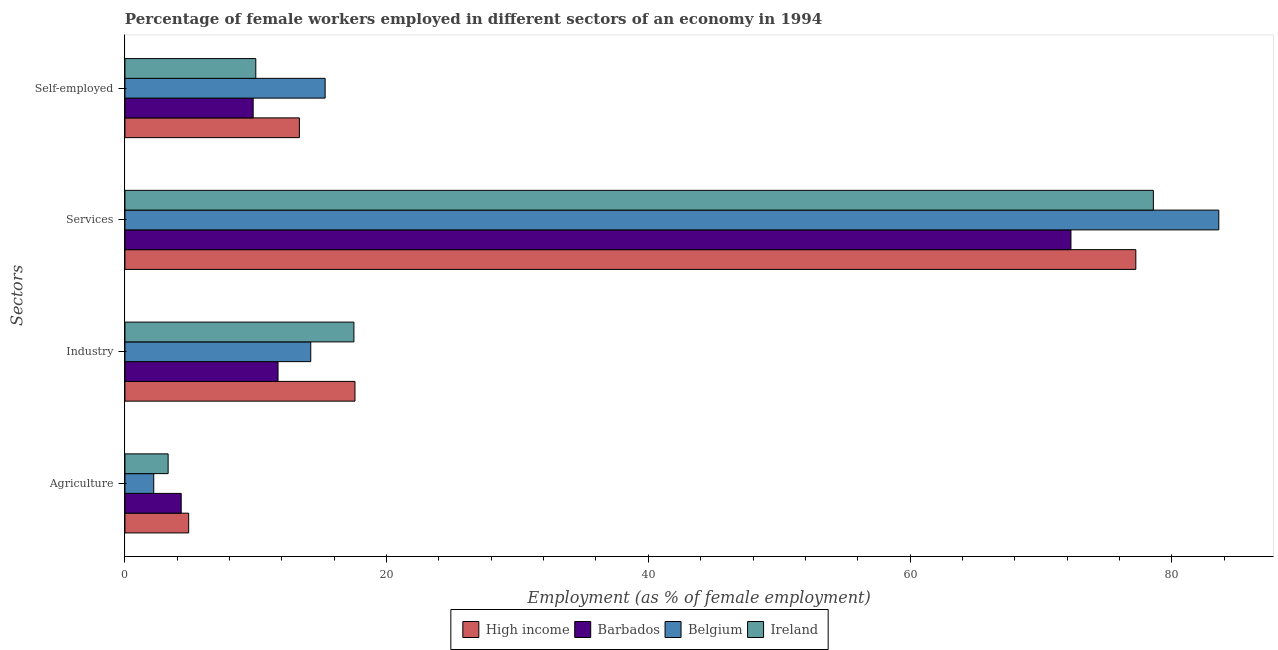How many different coloured bars are there?
Offer a very short reply. 4. How many groups of bars are there?
Provide a short and direct response. 4. Are the number of bars per tick equal to the number of legend labels?
Your response must be concise. Yes. Are the number of bars on each tick of the Y-axis equal?
Keep it short and to the point. Yes. How many bars are there on the 4th tick from the bottom?
Your answer should be very brief. 4. What is the label of the 3rd group of bars from the top?
Provide a short and direct response. Industry. What is the percentage of female workers in agriculture in High income?
Make the answer very short. 4.87. Across all countries, what is the maximum percentage of female workers in industry?
Keep it short and to the point. 17.58. Across all countries, what is the minimum percentage of self employed female workers?
Provide a succinct answer. 9.8. In which country was the percentage of female workers in services minimum?
Give a very brief answer. Barbados. What is the total percentage of female workers in services in the graph?
Ensure brevity in your answer.  311.76. What is the difference between the percentage of female workers in agriculture in High income and that in Belgium?
Ensure brevity in your answer.  2.67. What is the difference between the percentage of self employed female workers in Ireland and the percentage of female workers in agriculture in Belgium?
Ensure brevity in your answer.  7.8. What is the average percentage of female workers in services per country?
Give a very brief answer. 77.94. What is the difference between the percentage of female workers in industry and percentage of self employed female workers in Belgium?
Make the answer very short. -1.1. In how many countries, is the percentage of female workers in services greater than 44 %?
Offer a very short reply. 4. What is the ratio of the percentage of female workers in services in Ireland to that in Belgium?
Offer a terse response. 0.94. Is the percentage of self employed female workers in Barbados less than that in High income?
Give a very brief answer. Yes. What is the difference between the highest and the second highest percentage of female workers in services?
Provide a short and direct response. 5. What is the difference between the highest and the lowest percentage of self employed female workers?
Offer a terse response. 5.5. Is it the case that in every country, the sum of the percentage of female workers in agriculture and percentage of self employed female workers is greater than the sum of percentage of female workers in services and percentage of female workers in industry?
Provide a succinct answer. Yes. What does the 2nd bar from the top in Self-employed represents?
Keep it short and to the point. Belgium. What does the 2nd bar from the bottom in Agriculture represents?
Provide a succinct answer. Barbados. Are all the bars in the graph horizontal?
Provide a short and direct response. Yes. How many countries are there in the graph?
Your response must be concise. 4. What is the difference between two consecutive major ticks on the X-axis?
Offer a very short reply. 20. Does the graph contain grids?
Keep it short and to the point. No. Where does the legend appear in the graph?
Ensure brevity in your answer.  Bottom center. How many legend labels are there?
Offer a very short reply. 4. What is the title of the graph?
Your response must be concise. Percentage of female workers employed in different sectors of an economy in 1994. What is the label or title of the X-axis?
Provide a succinct answer. Employment (as % of female employment). What is the label or title of the Y-axis?
Provide a succinct answer. Sectors. What is the Employment (as % of female employment) in High income in Agriculture?
Give a very brief answer. 4.87. What is the Employment (as % of female employment) of Barbados in Agriculture?
Offer a very short reply. 4.3. What is the Employment (as % of female employment) of Belgium in Agriculture?
Give a very brief answer. 2.2. What is the Employment (as % of female employment) of Ireland in Agriculture?
Your response must be concise. 3.3. What is the Employment (as % of female employment) of High income in Industry?
Keep it short and to the point. 17.58. What is the Employment (as % of female employment) of Barbados in Industry?
Offer a very short reply. 11.7. What is the Employment (as % of female employment) of Belgium in Industry?
Your answer should be very brief. 14.2. What is the Employment (as % of female employment) in Ireland in Industry?
Offer a very short reply. 17.5. What is the Employment (as % of female employment) in High income in Services?
Offer a very short reply. 77.26. What is the Employment (as % of female employment) of Barbados in Services?
Provide a short and direct response. 72.3. What is the Employment (as % of female employment) in Belgium in Services?
Offer a very short reply. 83.6. What is the Employment (as % of female employment) of Ireland in Services?
Your answer should be very brief. 78.6. What is the Employment (as % of female employment) of High income in Self-employed?
Offer a terse response. 13.33. What is the Employment (as % of female employment) in Barbados in Self-employed?
Ensure brevity in your answer.  9.8. What is the Employment (as % of female employment) in Belgium in Self-employed?
Ensure brevity in your answer.  15.3. What is the Employment (as % of female employment) of Ireland in Self-employed?
Keep it short and to the point. 10. Across all Sectors, what is the maximum Employment (as % of female employment) in High income?
Ensure brevity in your answer.  77.26. Across all Sectors, what is the maximum Employment (as % of female employment) in Barbados?
Offer a very short reply. 72.3. Across all Sectors, what is the maximum Employment (as % of female employment) in Belgium?
Offer a very short reply. 83.6. Across all Sectors, what is the maximum Employment (as % of female employment) in Ireland?
Provide a succinct answer. 78.6. Across all Sectors, what is the minimum Employment (as % of female employment) in High income?
Make the answer very short. 4.87. Across all Sectors, what is the minimum Employment (as % of female employment) of Barbados?
Offer a very short reply. 4.3. Across all Sectors, what is the minimum Employment (as % of female employment) of Belgium?
Your answer should be very brief. 2.2. Across all Sectors, what is the minimum Employment (as % of female employment) in Ireland?
Offer a very short reply. 3.3. What is the total Employment (as % of female employment) of High income in the graph?
Provide a succinct answer. 113.04. What is the total Employment (as % of female employment) in Barbados in the graph?
Your answer should be very brief. 98.1. What is the total Employment (as % of female employment) in Belgium in the graph?
Ensure brevity in your answer.  115.3. What is the total Employment (as % of female employment) of Ireland in the graph?
Your response must be concise. 109.4. What is the difference between the Employment (as % of female employment) of High income in Agriculture and that in Industry?
Your answer should be compact. -12.71. What is the difference between the Employment (as % of female employment) of High income in Agriculture and that in Services?
Offer a terse response. -72.39. What is the difference between the Employment (as % of female employment) in Barbados in Agriculture and that in Services?
Your answer should be compact. -68. What is the difference between the Employment (as % of female employment) of Belgium in Agriculture and that in Services?
Offer a terse response. -81.4. What is the difference between the Employment (as % of female employment) of Ireland in Agriculture and that in Services?
Provide a succinct answer. -75.3. What is the difference between the Employment (as % of female employment) of High income in Agriculture and that in Self-employed?
Make the answer very short. -8.46. What is the difference between the Employment (as % of female employment) in Barbados in Agriculture and that in Self-employed?
Your answer should be compact. -5.5. What is the difference between the Employment (as % of female employment) in Belgium in Agriculture and that in Self-employed?
Your response must be concise. -13.1. What is the difference between the Employment (as % of female employment) in Ireland in Agriculture and that in Self-employed?
Give a very brief answer. -6.7. What is the difference between the Employment (as % of female employment) in High income in Industry and that in Services?
Provide a succinct answer. -59.68. What is the difference between the Employment (as % of female employment) in Barbados in Industry and that in Services?
Make the answer very short. -60.6. What is the difference between the Employment (as % of female employment) in Belgium in Industry and that in Services?
Make the answer very short. -69.4. What is the difference between the Employment (as % of female employment) in Ireland in Industry and that in Services?
Offer a very short reply. -61.1. What is the difference between the Employment (as % of female employment) in High income in Industry and that in Self-employed?
Provide a short and direct response. 4.25. What is the difference between the Employment (as % of female employment) of Barbados in Industry and that in Self-employed?
Provide a short and direct response. 1.9. What is the difference between the Employment (as % of female employment) in Ireland in Industry and that in Self-employed?
Keep it short and to the point. 7.5. What is the difference between the Employment (as % of female employment) of High income in Services and that in Self-employed?
Provide a succinct answer. 63.93. What is the difference between the Employment (as % of female employment) in Barbados in Services and that in Self-employed?
Your answer should be compact. 62.5. What is the difference between the Employment (as % of female employment) of Belgium in Services and that in Self-employed?
Provide a short and direct response. 68.3. What is the difference between the Employment (as % of female employment) in Ireland in Services and that in Self-employed?
Your response must be concise. 68.6. What is the difference between the Employment (as % of female employment) in High income in Agriculture and the Employment (as % of female employment) in Barbados in Industry?
Give a very brief answer. -6.83. What is the difference between the Employment (as % of female employment) of High income in Agriculture and the Employment (as % of female employment) of Belgium in Industry?
Offer a very short reply. -9.33. What is the difference between the Employment (as % of female employment) of High income in Agriculture and the Employment (as % of female employment) of Ireland in Industry?
Provide a succinct answer. -12.63. What is the difference between the Employment (as % of female employment) in Belgium in Agriculture and the Employment (as % of female employment) in Ireland in Industry?
Make the answer very short. -15.3. What is the difference between the Employment (as % of female employment) of High income in Agriculture and the Employment (as % of female employment) of Barbados in Services?
Offer a very short reply. -67.43. What is the difference between the Employment (as % of female employment) of High income in Agriculture and the Employment (as % of female employment) of Belgium in Services?
Offer a very short reply. -78.73. What is the difference between the Employment (as % of female employment) in High income in Agriculture and the Employment (as % of female employment) in Ireland in Services?
Your answer should be compact. -73.73. What is the difference between the Employment (as % of female employment) of Barbados in Agriculture and the Employment (as % of female employment) of Belgium in Services?
Give a very brief answer. -79.3. What is the difference between the Employment (as % of female employment) in Barbados in Agriculture and the Employment (as % of female employment) in Ireland in Services?
Your response must be concise. -74.3. What is the difference between the Employment (as % of female employment) of Belgium in Agriculture and the Employment (as % of female employment) of Ireland in Services?
Provide a succinct answer. -76.4. What is the difference between the Employment (as % of female employment) in High income in Agriculture and the Employment (as % of female employment) in Barbados in Self-employed?
Provide a short and direct response. -4.93. What is the difference between the Employment (as % of female employment) of High income in Agriculture and the Employment (as % of female employment) of Belgium in Self-employed?
Provide a succinct answer. -10.43. What is the difference between the Employment (as % of female employment) of High income in Agriculture and the Employment (as % of female employment) of Ireland in Self-employed?
Provide a succinct answer. -5.13. What is the difference between the Employment (as % of female employment) of Barbados in Agriculture and the Employment (as % of female employment) of Ireland in Self-employed?
Offer a terse response. -5.7. What is the difference between the Employment (as % of female employment) in Belgium in Agriculture and the Employment (as % of female employment) in Ireland in Self-employed?
Keep it short and to the point. -7.8. What is the difference between the Employment (as % of female employment) of High income in Industry and the Employment (as % of female employment) of Barbados in Services?
Keep it short and to the point. -54.72. What is the difference between the Employment (as % of female employment) in High income in Industry and the Employment (as % of female employment) in Belgium in Services?
Your answer should be compact. -66.02. What is the difference between the Employment (as % of female employment) of High income in Industry and the Employment (as % of female employment) of Ireland in Services?
Provide a succinct answer. -61.02. What is the difference between the Employment (as % of female employment) of Barbados in Industry and the Employment (as % of female employment) of Belgium in Services?
Ensure brevity in your answer.  -71.9. What is the difference between the Employment (as % of female employment) of Barbados in Industry and the Employment (as % of female employment) of Ireland in Services?
Your answer should be compact. -66.9. What is the difference between the Employment (as % of female employment) in Belgium in Industry and the Employment (as % of female employment) in Ireland in Services?
Offer a terse response. -64.4. What is the difference between the Employment (as % of female employment) in High income in Industry and the Employment (as % of female employment) in Barbados in Self-employed?
Provide a succinct answer. 7.78. What is the difference between the Employment (as % of female employment) in High income in Industry and the Employment (as % of female employment) in Belgium in Self-employed?
Offer a terse response. 2.28. What is the difference between the Employment (as % of female employment) in High income in Industry and the Employment (as % of female employment) in Ireland in Self-employed?
Your response must be concise. 7.58. What is the difference between the Employment (as % of female employment) in Belgium in Industry and the Employment (as % of female employment) in Ireland in Self-employed?
Provide a short and direct response. 4.2. What is the difference between the Employment (as % of female employment) of High income in Services and the Employment (as % of female employment) of Barbados in Self-employed?
Ensure brevity in your answer.  67.46. What is the difference between the Employment (as % of female employment) of High income in Services and the Employment (as % of female employment) of Belgium in Self-employed?
Provide a succinct answer. 61.96. What is the difference between the Employment (as % of female employment) in High income in Services and the Employment (as % of female employment) in Ireland in Self-employed?
Your response must be concise. 67.26. What is the difference between the Employment (as % of female employment) of Barbados in Services and the Employment (as % of female employment) of Belgium in Self-employed?
Offer a terse response. 57. What is the difference between the Employment (as % of female employment) of Barbados in Services and the Employment (as % of female employment) of Ireland in Self-employed?
Provide a short and direct response. 62.3. What is the difference between the Employment (as % of female employment) of Belgium in Services and the Employment (as % of female employment) of Ireland in Self-employed?
Keep it short and to the point. 73.6. What is the average Employment (as % of female employment) of High income per Sectors?
Your answer should be compact. 28.26. What is the average Employment (as % of female employment) in Barbados per Sectors?
Ensure brevity in your answer.  24.52. What is the average Employment (as % of female employment) in Belgium per Sectors?
Make the answer very short. 28.82. What is the average Employment (as % of female employment) in Ireland per Sectors?
Make the answer very short. 27.35. What is the difference between the Employment (as % of female employment) of High income and Employment (as % of female employment) of Barbados in Agriculture?
Offer a terse response. 0.57. What is the difference between the Employment (as % of female employment) of High income and Employment (as % of female employment) of Belgium in Agriculture?
Make the answer very short. 2.67. What is the difference between the Employment (as % of female employment) in High income and Employment (as % of female employment) in Ireland in Agriculture?
Provide a short and direct response. 1.57. What is the difference between the Employment (as % of female employment) in Barbados and Employment (as % of female employment) in Belgium in Agriculture?
Offer a very short reply. 2.1. What is the difference between the Employment (as % of female employment) of Belgium and Employment (as % of female employment) of Ireland in Agriculture?
Ensure brevity in your answer.  -1.1. What is the difference between the Employment (as % of female employment) of High income and Employment (as % of female employment) of Barbados in Industry?
Your answer should be compact. 5.88. What is the difference between the Employment (as % of female employment) of High income and Employment (as % of female employment) of Belgium in Industry?
Offer a very short reply. 3.38. What is the difference between the Employment (as % of female employment) in High income and Employment (as % of female employment) in Ireland in Industry?
Ensure brevity in your answer.  0.08. What is the difference between the Employment (as % of female employment) in Barbados and Employment (as % of female employment) in Ireland in Industry?
Your answer should be compact. -5.8. What is the difference between the Employment (as % of female employment) of High income and Employment (as % of female employment) of Barbados in Services?
Offer a terse response. 4.96. What is the difference between the Employment (as % of female employment) of High income and Employment (as % of female employment) of Belgium in Services?
Offer a terse response. -6.34. What is the difference between the Employment (as % of female employment) of High income and Employment (as % of female employment) of Ireland in Services?
Ensure brevity in your answer.  -1.34. What is the difference between the Employment (as % of female employment) of High income and Employment (as % of female employment) of Barbados in Self-employed?
Provide a succinct answer. 3.53. What is the difference between the Employment (as % of female employment) in High income and Employment (as % of female employment) in Belgium in Self-employed?
Your response must be concise. -1.97. What is the difference between the Employment (as % of female employment) in High income and Employment (as % of female employment) in Ireland in Self-employed?
Ensure brevity in your answer.  3.33. What is the difference between the Employment (as % of female employment) of Barbados and Employment (as % of female employment) of Belgium in Self-employed?
Provide a succinct answer. -5.5. What is the difference between the Employment (as % of female employment) in Barbados and Employment (as % of female employment) in Ireland in Self-employed?
Provide a succinct answer. -0.2. What is the difference between the Employment (as % of female employment) in Belgium and Employment (as % of female employment) in Ireland in Self-employed?
Make the answer very short. 5.3. What is the ratio of the Employment (as % of female employment) of High income in Agriculture to that in Industry?
Offer a terse response. 0.28. What is the ratio of the Employment (as % of female employment) of Barbados in Agriculture to that in Industry?
Keep it short and to the point. 0.37. What is the ratio of the Employment (as % of female employment) in Belgium in Agriculture to that in Industry?
Your response must be concise. 0.15. What is the ratio of the Employment (as % of female employment) of Ireland in Agriculture to that in Industry?
Offer a terse response. 0.19. What is the ratio of the Employment (as % of female employment) of High income in Agriculture to that in Services?
Provide a short and direct response. 0.06. What is the ratio of the Employment (as % of female employment) of Barbados in Agriculture to that in Services?
Provide a succinct answer. 0.06. What is the ratio of the Employment (as % of female employment) in Belgium in Agriculture to that in Services?
Provide a succinct answer. 0.03. What is the ratio of the Employment (as % of female employment) of Ireland in Agriculture to that in Services?
Your answer should be compact. 0.04. What is the ratio of the Employment (as % of female employment) in High income in Agriculture to that in Self-employed?
Ensure brevity in your answer.  0.37. What is the ratio of the Employment (as % of female employment) of Barbados in Agriculture to that in Self-employed?
Give a very brief answer. 0.44. What is the ratio of the Employment (as % of female employment) of Belgium in Agriculture to that in Self-employed?
Give a very brief answer. 0.14. What is the ratio of the Employment (as % of female employment) of Ireland in Agriculture to that in Self-employed?
Keep it short and to the point. 0.33. What is the ratio of the Employment (as % of female employment) of High income in Industry to that in Services?
Make the answer very short. 0.23. What is the ratio of the Employment (as % of female employment) of Barbados in Industry to that in Services?
Your answer should be compact. 0.16. What is the ratio of the Employment (as % of female employment) in Belgium in Industry to that in Services?
Provide a succinct answer. 0.17. What is the ratio of the Employment (as % of female employment) in Ireland in Industry to that in Services?
Provide a short and direct response. 0.22. What is the ratio of the Employment (as % of female employment) of High income in Industry to that in Self-employed?
Make the answer very short. 1.32. What is the ratio of the Employment (as % of female employment) of Barbados in Industry to that in Self-employed?
Ensure brevity in your answer.  1.19. What is the ratio of the Employment (as % of female employment) in Belgium in Industry to that in Self-employed?
Provide a short and direct response. 0.93. What is the ratio of the Employment (as % of female employment) of Ireland in Industry to that in Self-employed?
Make the answer very short. 1.75. What is the ratio of the Employment (as % of female employment) in High income in Services to that in Self-employed?
Offer a terse response. 5.79. What is the ratio of the Employment (as % of female employment) in Barbados in Services to that in Self-employed?
Your answer should be compact. 7.38. What is the ratio of the Employment (as % of female employment) of Belgium in Services to that in Self-employed?
Provide a short and direct response. 5.46. What is the ratio of the Employment (as % of female employment) in Ireland in Services to that in Self-employed?
Ensure brevity in your answer.  7.86. What is the difference between the highest and the second highest Employment (as % of female employment) in High income?
Your answer should be very brief. 59.68. What is the difference between the highest and the second highest Employment (as % of female employment) of Barbados?
Provide a succinct answer. 60.6. What is the difference between the highest and the second highest Employment (as % of female employment) of Belgium?
Offer a terse response. 68.3. What is the difference between the highest and the second highest Employment (as % of female employment) in Ireland?
Your answer should be compact. 61.1. What is the difference between the highest and the lowest Employment (as % of female employment) of High income?
Provide a short and direct response. 72.39. What is the difference between the highest and the lowest Employment (as % of female employment) of Belgium?
Your answer should be very brief. 81.4. What is the difference between the highest and the lowest Employment (as % of female employment) of Ireland?
Ensure brevity in your answer.  75.3. 